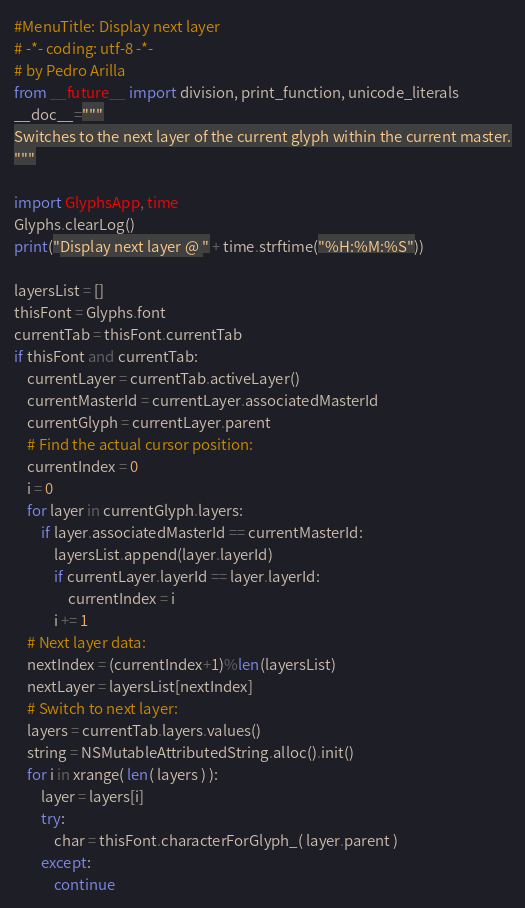Convert code to text. <code><loc_0><loc_0><loc_500><loc_500><_Python_>#MenuTitle: Display next layer
# -*- coding: utf-8 -*-
# by Pedro Arilla
from __future__ import division, print_function, unicode_literals
__doc__="""
Switches to the next layer of the current glyph within the current master.
"""

import GlyphsApp, time
Glyphs.clearLog()
print("Display next layer @ " + time.strftime("%H:%M:%S"))

layersList = []
thisFont = Glyphs.font
currentTab = thisFont.currentTab
if thisFont and currentTab:
	currentLayer = currentTab.activeLayer()
	currentMasterId = currentLayer.associatedMasterId
	currentGlyph = currentLayer.parent
	# Find the actual cursor position:
	currentIndex = 0
	i = 0
	for layer in currentGlyph.layers:
		if layer.associatedMasterId == currentMasterId:
			layersList.append(layer.layerId)
			if currentLayer.layerId == layer.layerId:
				currentIndex = i
			i += 1
	# Next layer data:
	nextIndex = (currentIndex+1)%len(layersList)
	nextLayer = layersList[nextIndex]
	# Switch to next layer:
	layers = currentTab.layers.values()
	string = NSMutableAttributedString.alloc().init()
	for i in xrange( len( layers ) ):
		layer = layers[i]
		try:
			char = thisFont.characterForGlyph_( layer.parent )
		except:
			continue</code> 